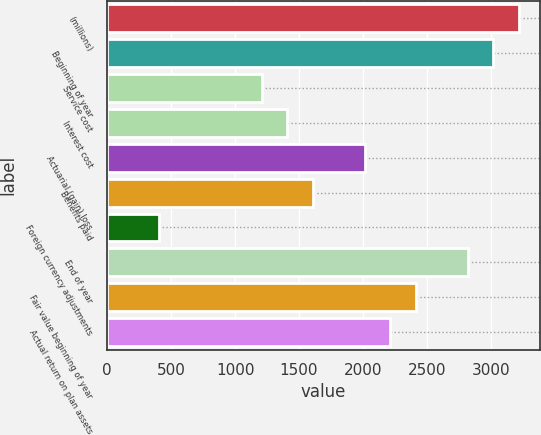Convert chart. <chart><loc_0><loc_0><loc_500><loc_500><bar_chart><fcel>(millions)<fcel>Beginning of year<fcel>Service cost<fcel>Interest cost<fcel>Actuarial (gain) loss<fcel>Benefits paid<fcel>Foreign currency adjustments<fcel>End of year<fcel>Fair value beginning of year<fcel>Actual return on plan assets<nl><fcel>3220.2<fcel>3019<fcel>1208.2<fcel>1409.4<fcel>2013<fcel>1610.6<fcel>403.4<fcel>2817.8<fcel>2415.4<fcel>2214.2<nl></chart> 